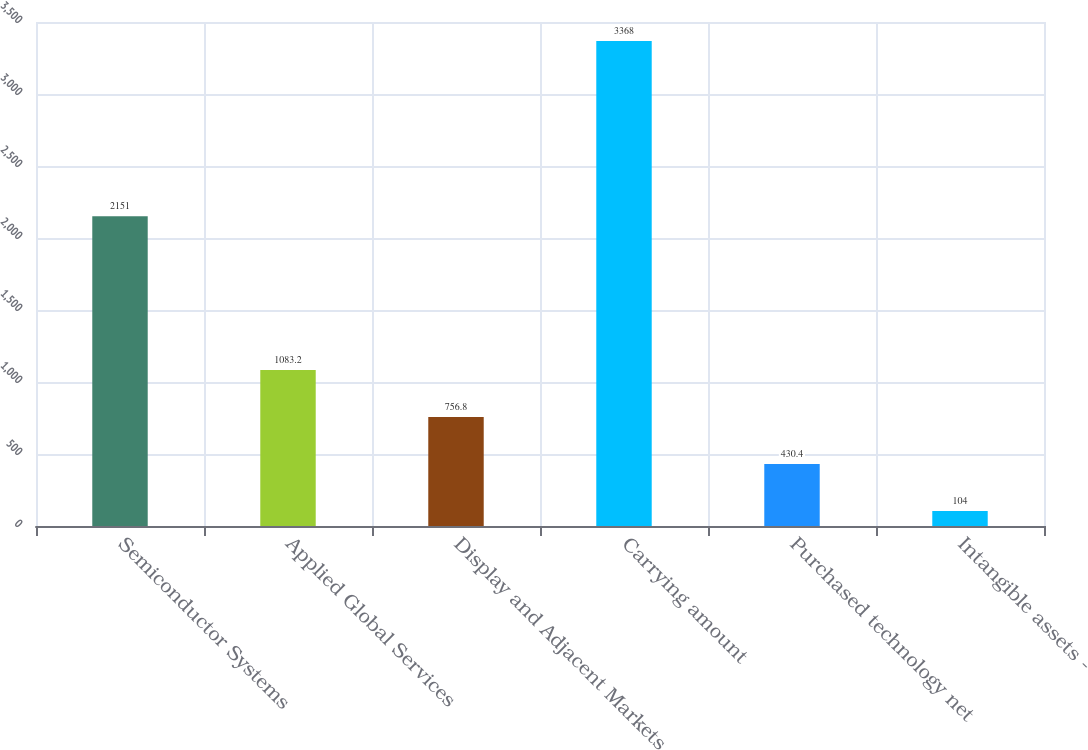Convert chart to OTSL. <chart><loc_0><loc_0><loc_500><loc_500><bar_chart><fcel>Semiconductor Systems<fcel>Applied Global Services<fcel>Display and Adjacent Markets<fcel>Carrying amount<fcel>Purchased technology net<fcel>Intangible assets -<nl><fcel>2151<fcel>1083.2<fcel>756.8<fcel>3368<fcel>430.4<fcel>104<nl></chart> 